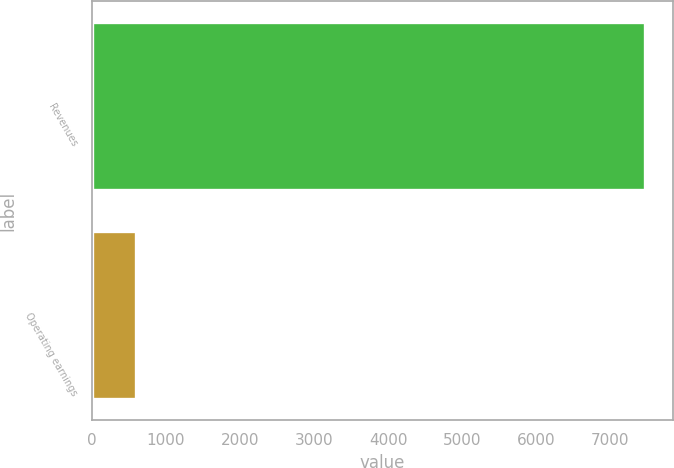Convert chart. <chart><loc_0><loc_0><loc_500><loc_500><bar_chart><fcel>Revenues<fcel>Operating earnings<nl><fcel>7471<fcel>595<nl></chart> 